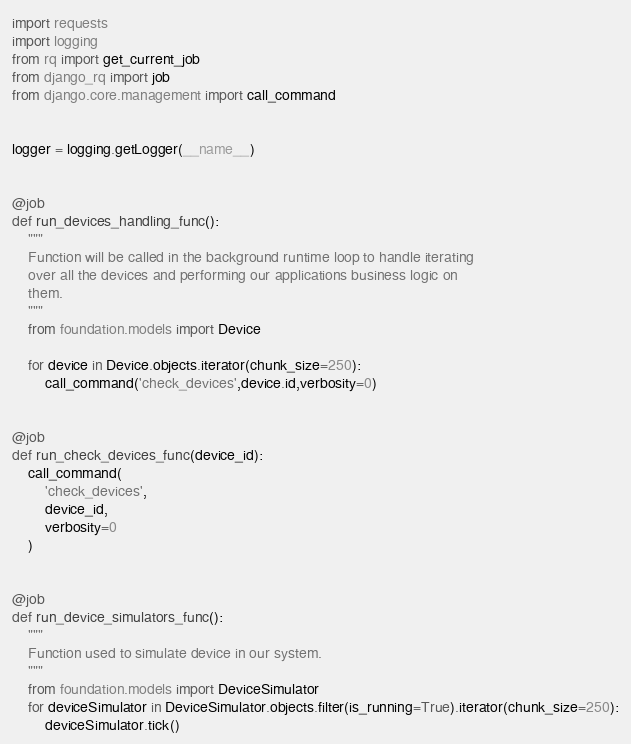<code> <loc_0><loc_0><loc_500><loc_500><_Python_>import requests
import logging
from rq import get_current_job
from django_rq import job
from django.core.management import call_command


logger = logging.getLogger(__name__)


@job
def run_devices_handling_func():
    """
    Function will be called in the background runtime loop to handle iterating
    over all the devices and performing our applications business logic on
    them.
    """
    from foundation.models import Device

    for device in Device.objects.iterator(chunk_size=250):
        call_command('check_devices',device.id,verbosity=0)


@job
def run_check_devices_func(device_id):
    call_command(
        'check_devices',
        device_id,
        verbosity=0
    )


@job
def run_device_simulators_func():
    """
    Function used to simulate device in our system.
    """
    from foundation.models import DeviceSimulator
    for deviceSimulator in DeviceSimulator.objects.filter(is_running=True).iterator(chunk_size=250):
        deviceSimulator.tick()
</code> 